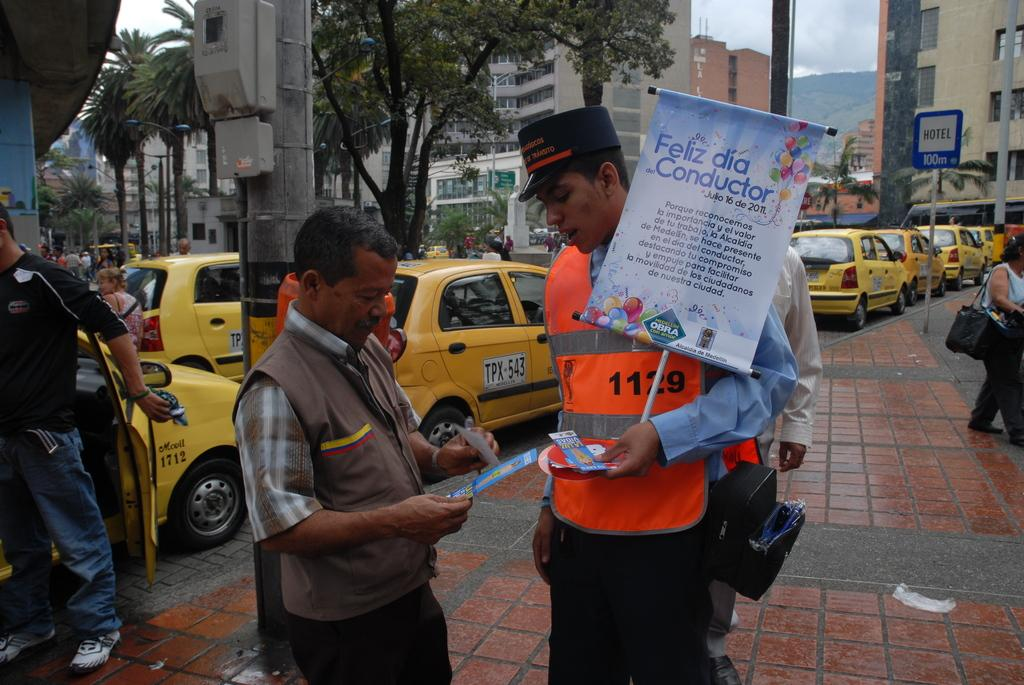Provide a one-sentence caption for the provided image. a person walking with a sign that has the word feliz on it. 